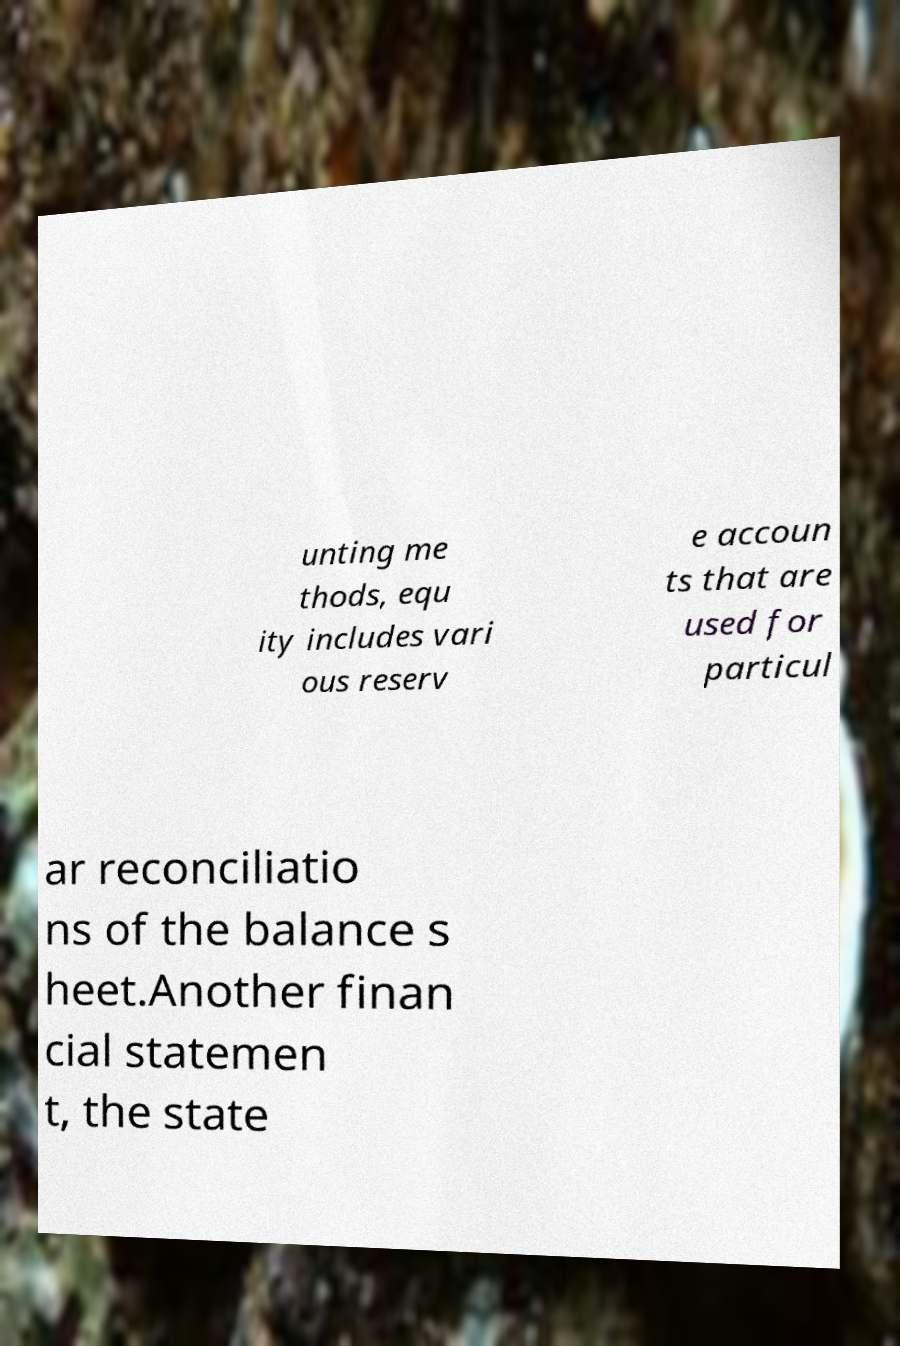What messages or text are displayed in this image? I need them in a readable, typed format. unting me thods, equ ity includes vari ous reserv e accoun ts that are used for particul ar reconciliatio ns of the balance s heet.Another finan cial statemen t, the state 